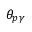Convert formula to latex. <formula><loc_0><loc_0><loc_500><loc_500>\theta _ { p \gamma }</formula> 